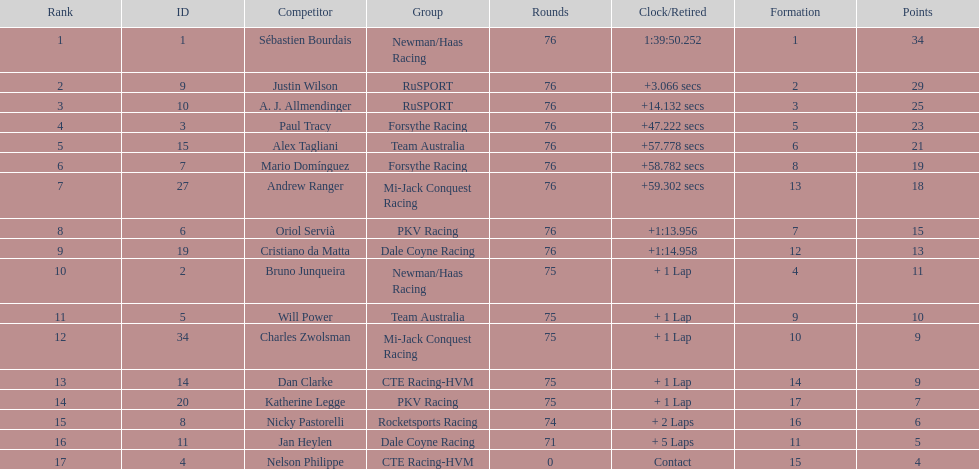What was the total points that canada earned together? 62. 